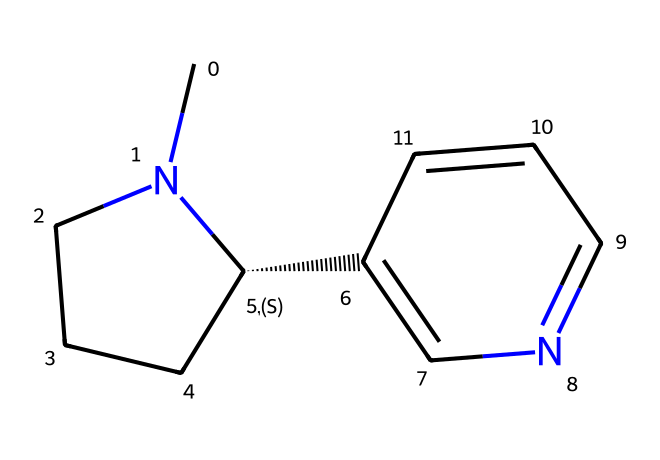What is the total number of nitrogen atoms in this molecule? By examining the SMILES representation, we see that there are two nitrogen atoms present in the structure.
Answer: 2 What type of compound is this molecule classified as? This chemical consists of a pyridine ring and saturated rings containing nitrogen, which is characteristic of alkaloids; therefore, this molecule is classified as an alkaloid.
Answer: alkaloid How many carbon atoms are there in this chemical? Counting the carbon atoms present in the SMILES structure, we find a total of ten carbon atoms, which are part of the various rings and chains present.
Answer: 10 Does this molecule contain any double bonds? By analyzing the structure, there is a double bond present in the pyridine ring portion of the molecule, confirming the presence of unsaturation.
Answer: yes What is the likely effect of nicotine on memory recall during oral history sessions? Given that nicotine can enhance attention and memory recall due to its effects on neurotransmitters and brain activity, it is likely to positively impact memory recall during oral history sessions.
Answer: positive What is the molecular weight of this compound approximately? To calculate the molecular weight, we sum the atomic weights of all the atoms present based on the structural formula, leading to an approximate molecular weight of about 162 grams per mole.
Answer: 162 Which part of this chemical indicates its pharmacological activity? The nitrogen atoms are responsible for its pharmacological activity since they play a key role in interacting with neurotransmitter systems in the body.
Answer: nitrogen atoms 